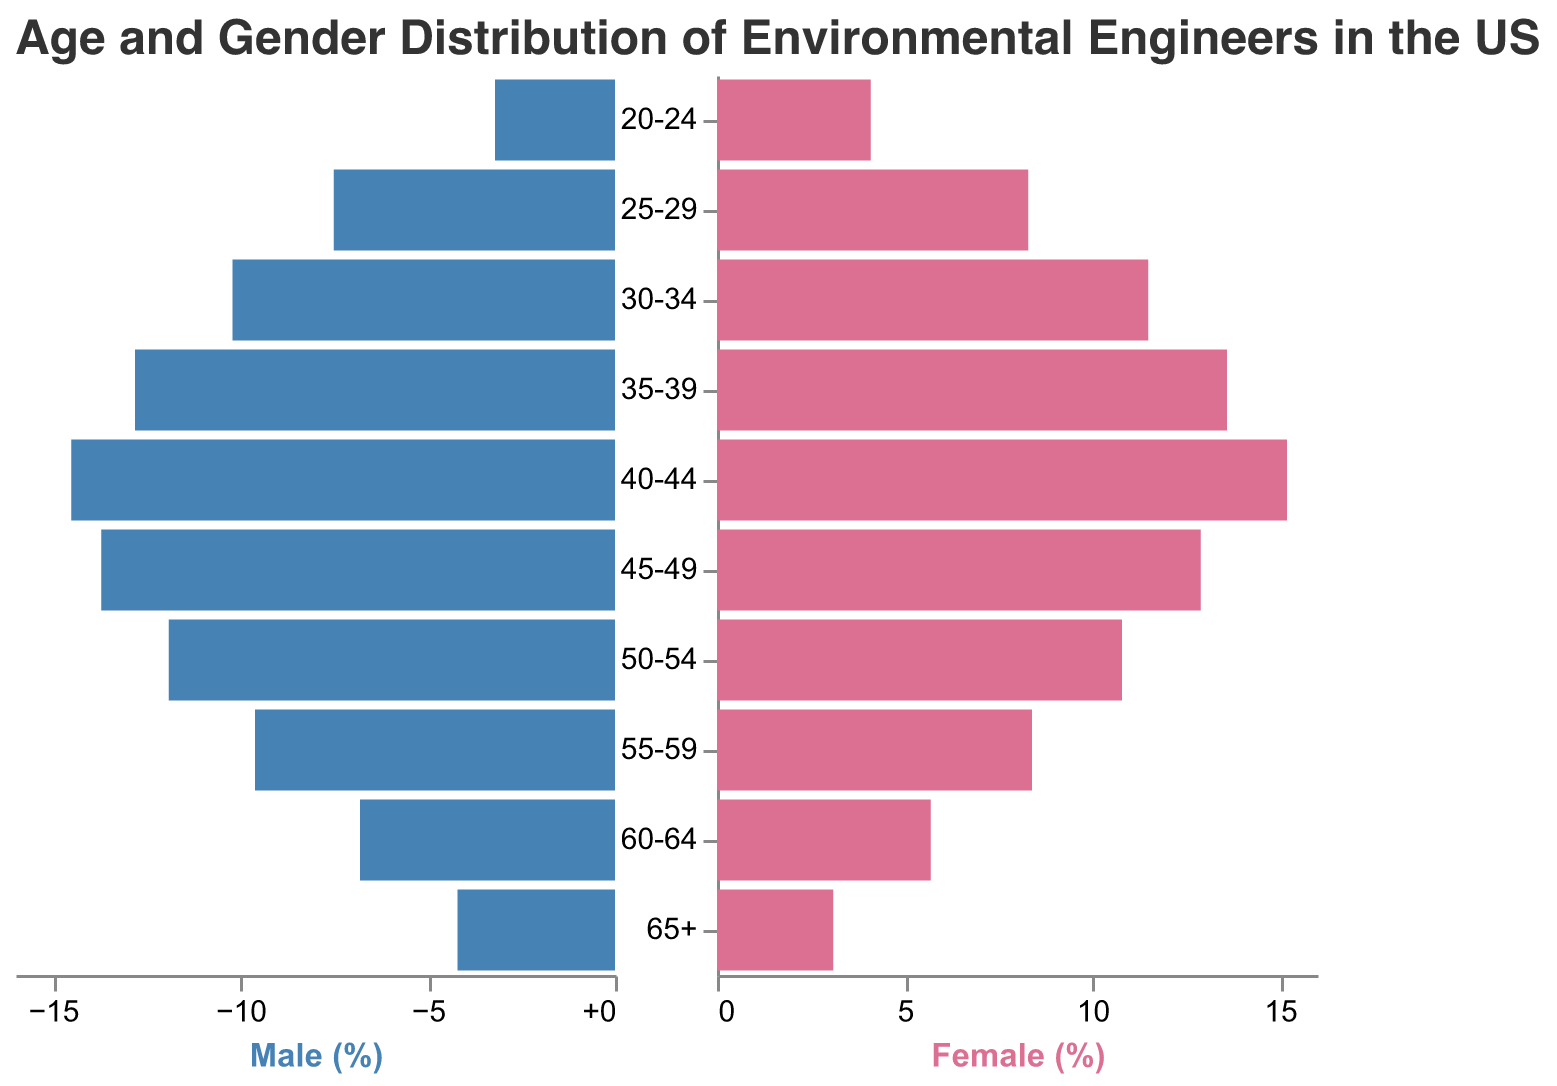What is the title of the population pyramid? The title is prominently displayed at the top of the figure. It reads, "Age and Gender Distribution of Environmental Engineers in the US."
Answer: Age and Gender Distribution of Environmental Engineers in the US Which age group has the highest proportion of female environmental engineers? The bar representing the age group with the longest female section indicates the highest proportion. According to the figure, the age group 40-44 has the highest proportion of female environmental engineers.
Answer: 40-44 What is the percentage of male environmental engineers in the 30-34 age group? By looking at the male section of the population pyramid for the age group 30-34, the length of the corresponding bar indicates the percentage. According to the figure, it is 10.2%.
Answer: 10.2% In which age group is the discrepancy between male and female environmental engineers the largest? To find this, calculate the absolute difference between the percentages of males and females in each age group and identify the largest value. The largest discrepancy is in the 40-44 age group (15.2% - 14.5% = 0.7%).
Answer: 40-44 How does the percentage of female environmental engineers in the 45-49 age group compare to those in the 35-39 age group? Compare the lengths of the bars for females in these age groups. According to the figure, the percentage in the 45-49 age group (12.9%) is lower than that in the 35-39 age group (13.6%).
Answer: The percentage is lower What is the sum of percentages of male environmental engineers in the 50-54 and 55-59 age groups? Add the percentages of male engineers in the two specified age groups. In the 50-54 age group, it is 11.9%, and in the 55-59 age group, it is 9.6%. 11.9 + 9.6 = 21.5%.
Answer: 21.5% Which gender has a higher percentage in the 60-64 age group, and by how much? Compare the percentages for males and females in the 60-64 age group. Males have 6.8%, and females have 5.7%. The difference is 6.8% - 5.7% = 1.1%.
Answer: Males by 1.1% Identify the trend in the percentage of male environmental engineers from the 20-24 age group to the 65+ age group. Observing the bars for males across the age groups from left to right, the percentages generally increase from 20-24 until 40-44, then start to decrease from 45-49 onwards.
Answer: Increases then decreases What is the total percentage of female environmental engineers in the age groups 20-24 and 25-29? Add the percentages of female engineers in these two age groups. In the 20-24 age group, it is 4.1%, and in the 25-29 age group, it is 8.3%. 4.1 + 8.3 = 12.4%.
Answer: 12.4% How does the gender ratio appear to change for environmental engineers as they age? Observing the figure, it appears that the percentage of females is slightly higher in the younger age groups, but as age increases, the percentage of males tends to become relatively higher, although it still remains within a close range.
Answer: Females higher in younger, males relatively higher in older 